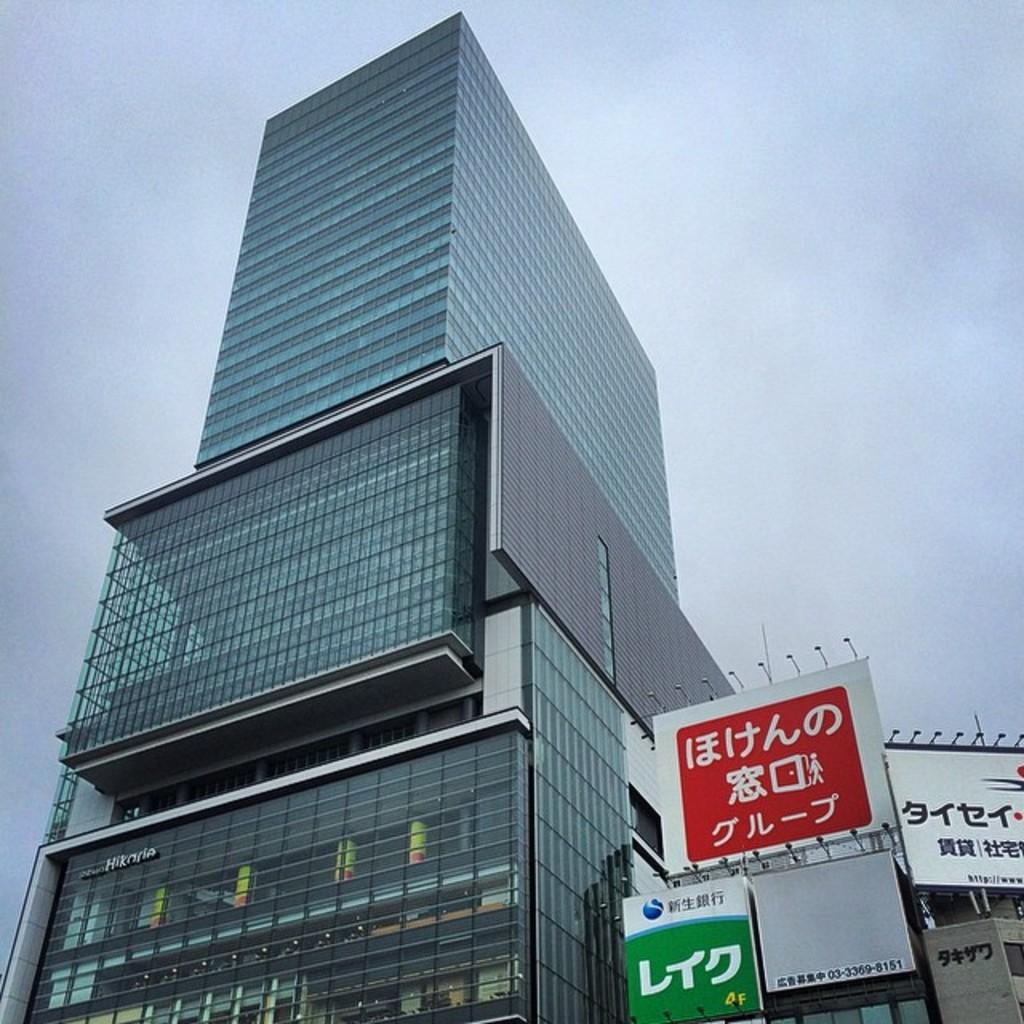What type of structure is present in the image? There is a building in the image. What can be seen in the bottom right corner of the image? There are boards in the bottom right corner of the image. What is written on the boards? There is text on the boards. What is visible in the background of the image? The sky is visible in the background of the image. What type of tax can be seen on the tail of the animal in the image? There is no animal or tax present in the image; it features a building and boards with text. 